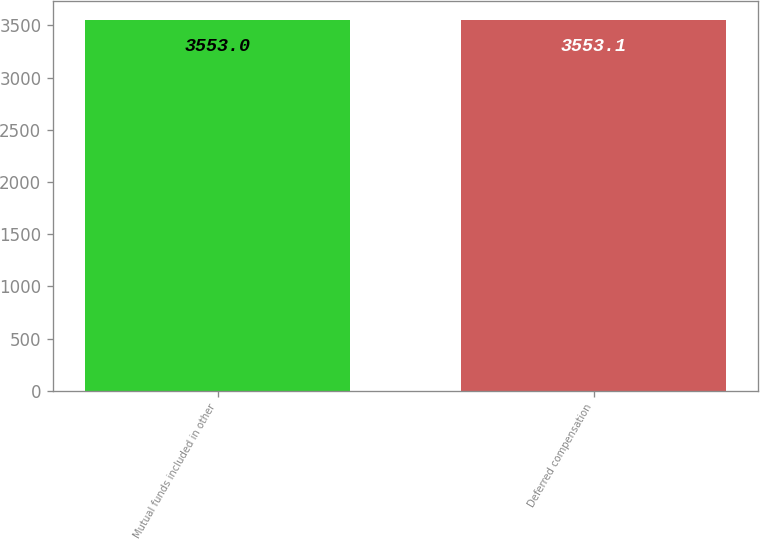Convert chart to OTSL. <chart><loc_0><loc_0><loc_500><loc_500><bar_chart><fcel>Mutual funds included in other<fcel>Deferred compensation<nl><fcel>3553<fcel>3553.1<nl></chart> 